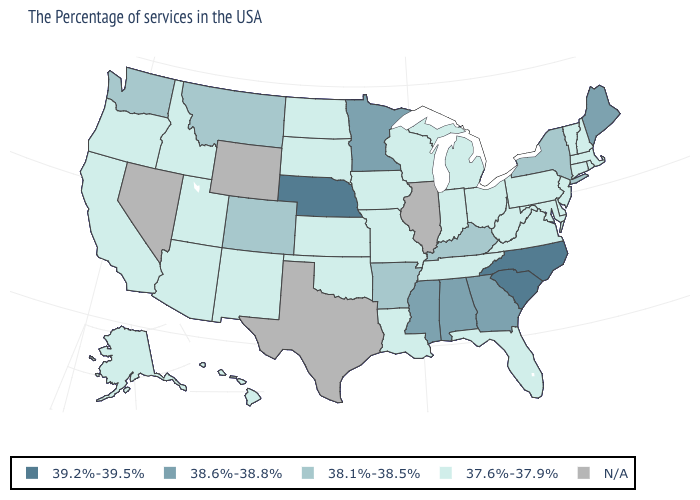Does the map have missing data?
Quick response, please. Yes. Among the states that border Oklahoma , does Arkansas have the highest value?
Keep it brief. Yes. What is the value of Vermont?
Be succinct. 37.6%-37.9%. What is the value of Nevada?
Write a very short answer. N/A. Name the states that have a value in the range N/A?
Be succinct. Illinois, Texas, Wyoming, Nevada. Name the states that have a value in the range 38.1%-38.5%?
Quick response, please. New York, Kentucky, Arkansas, Colorado, Montana, Washington. Is the legend a continuous bar?
Write a very short answer. No. Which states have the highest value in the USA?
Be succinct. North Carolina, South Carolina, Nebraska. What is the value of Maine?
Quick response, please. 38.6%-38.8%. Which states hav the highest value in the South?
Quick response, please. North Carolina, South Carolina. What is the value of Tennessee?
Answer briefly. 37.6%-37.9%. Does the map have missing data?
Be succinct. Yes. Among the states that border New Hampshire , which have the lowest value?
Keep it brief. Massachusetts, Vermont. 